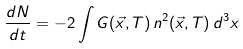Convert formula to latex. <formula><loc_0><loc_0><loc_500><loc_500>\frac { d N } { d t } = - 2 \int G ( \vec { x } , T ) \, n ^ { 2 } ( \vec { x } , T ) \, d ^ { 3 } x</formula> 